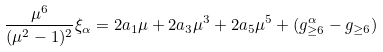<formula> <loc_0><loc_0><loc_500><loc_500>\frac { \mu ^ { 6 } } { ( \mu ^ { 2 } - 1 ) ^ { 2 } } \xi _ { \alpha } = 2 a _ { 1 } \mu + 2 a _ { 3 } \mu ^ { 3 } + 2 a _ { 5 } \mu ^ { 5 } + ( g _ { \geq 6 } ^ { \alpha } - g _ { \geq 6 } )</formula> 